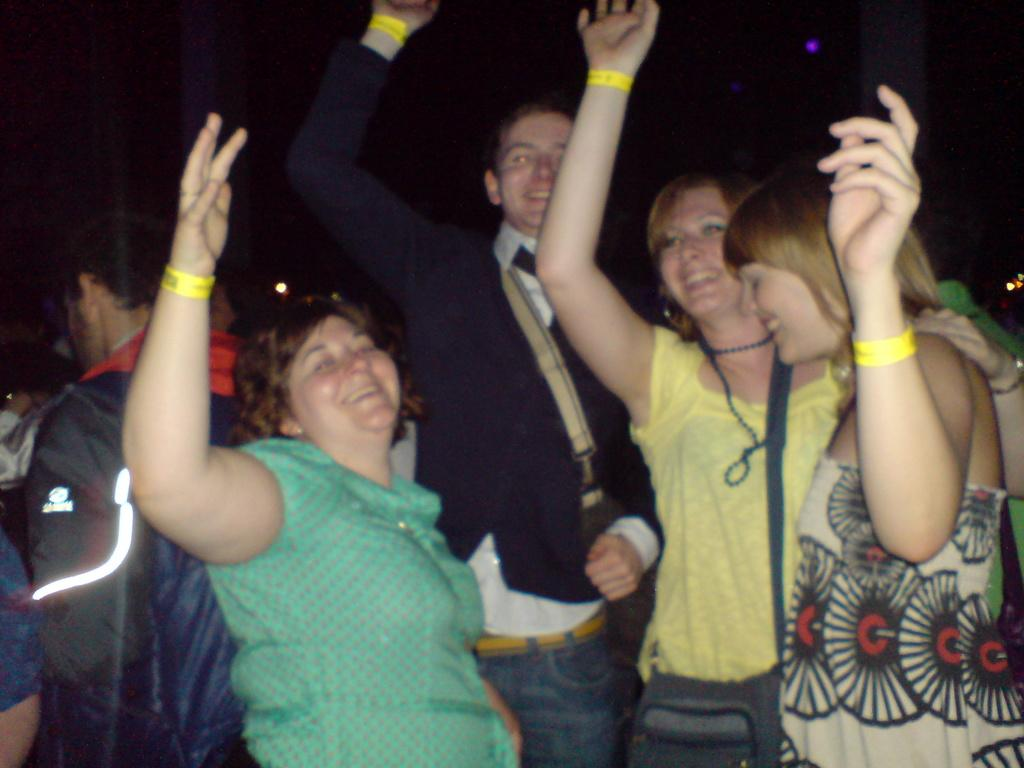What is happening in the image involving a group of people? There is a group of people in the image, and they are standing and smiling. What objects can be seen with the group of people? There are bags in the image. What can be observed about the lighting in the image? The background of the image is dark. What type of bubble can be seen floating near the group of people in the image? There is no bubble present in the image. What health advice can be given to the group of people in the image? We cannot provide health advice based on the image alone, as we do not have any information about their health or well-being. 